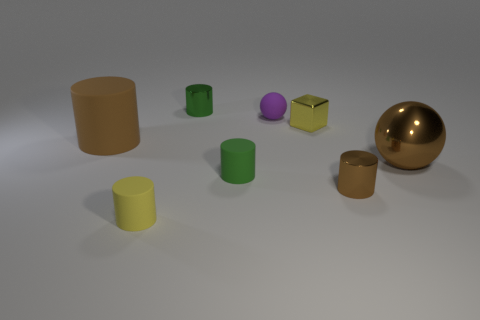Add 1 brown matte objects. How many objects exist? 9 Subtract all tiny shiny cylinders. How many cylinders are left? 3 Subtract all brown spheres. How many spheres are left? 1 Subtract all cubes. How many objects are left? 7 Subtract 1 blocks. How many blocks are left? 0 Subtract all large green metal cylinders. Subtract all yellow metal cubes. How many objects are left? 7 Add 1 green things. How many green things are left? 3 Add 7 small cyan matte cubes. How many small cyan matte cubes exist? 7 Subtract 0 cyan balls. How many objects are left? 8 Subtract all brown balls. Subtract all purple cubes. How many balls are left? 1 